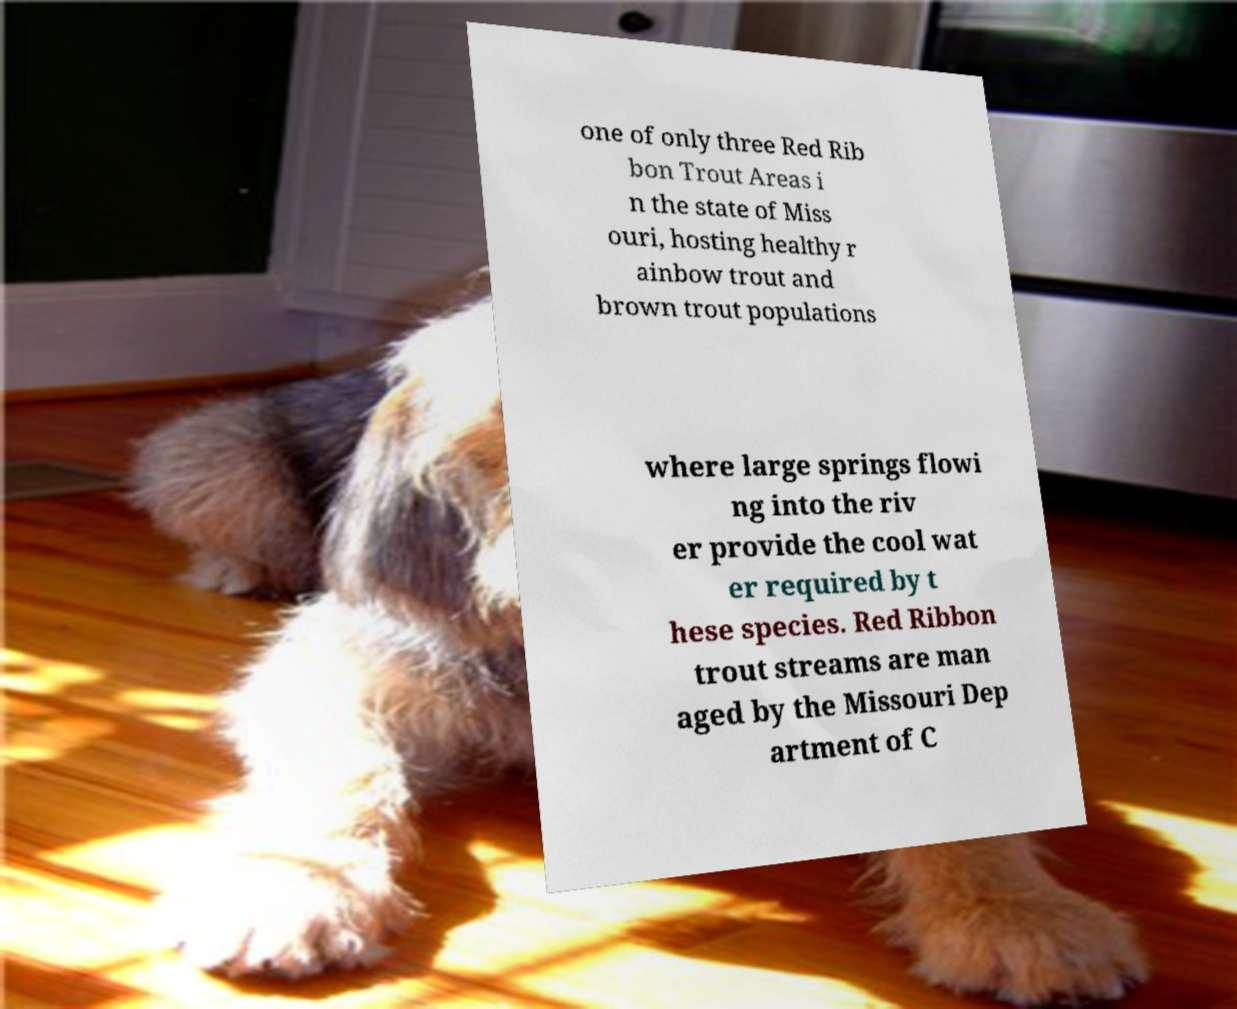Can you read and provide the text displayed in the image?This photo seems to have some interesting text. Can you extract and type it out for me? one of only three Red Rib bon Trout Areas i n the state of Miss ouri, hosting healthy r ainbow trout and brown trout populations where large springs flowi ng into the riv er provide the cool wat er required by t hese species. Red Ribbon trout streams are man aged by the Missouri Dep artment of C 